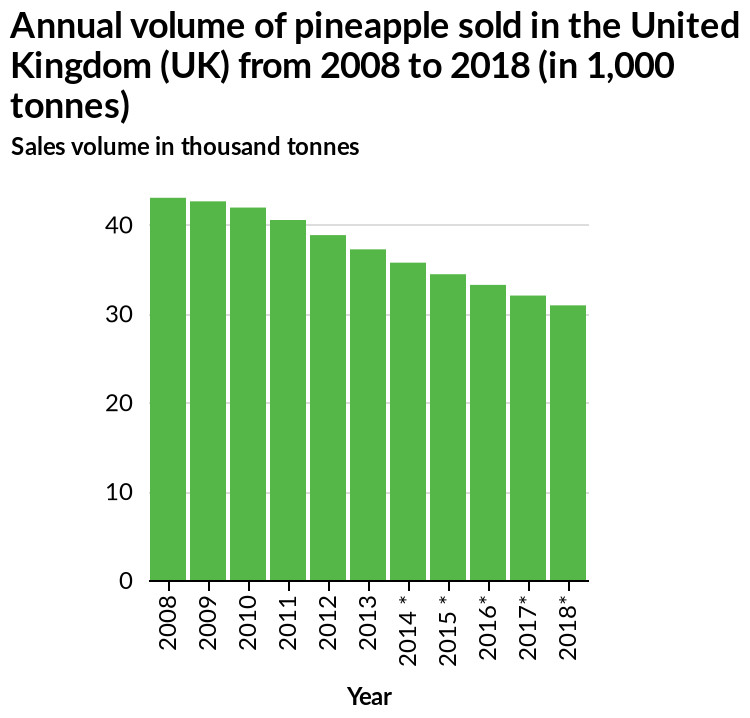<image>
please summary the statistics and relations of the chart Pineapple sales are declining between  2008 to 2018. 